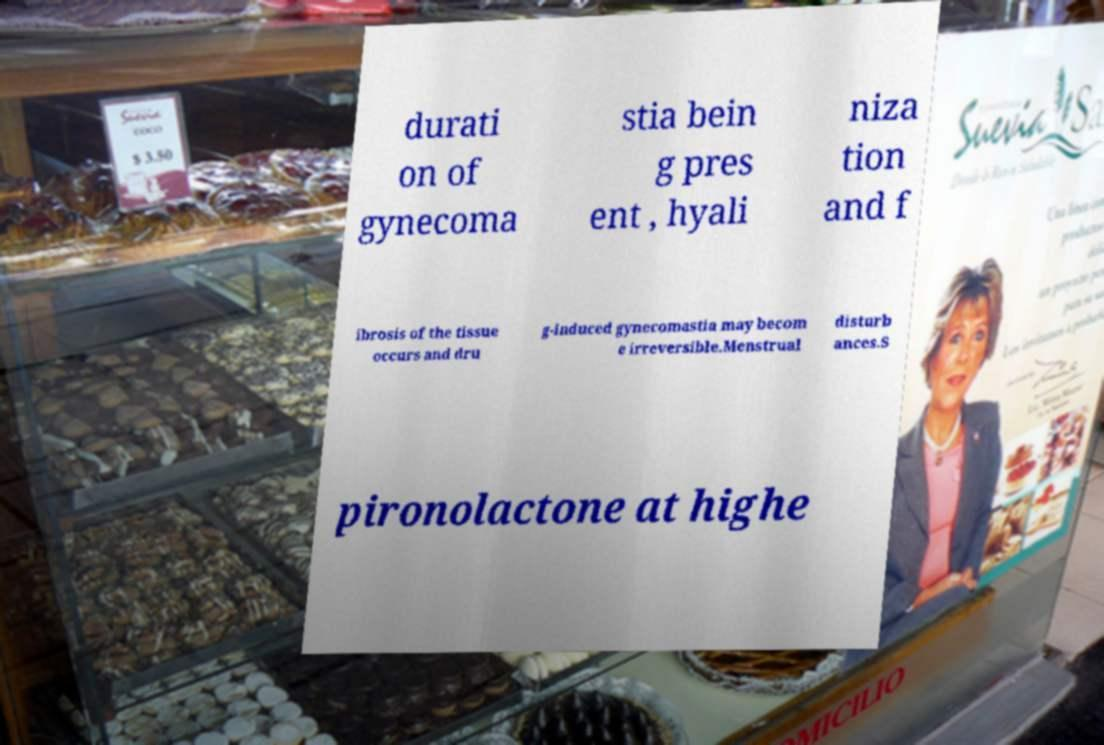Can you read and provide the text displayed in the image?This photo seems to have some interesting text. Can you extract and type it out for me? durati on of gynecoma stia bein g pres ent , hyali niza tion and f ibrosis of the tissue occurs and dru g-induced gynecomastia may becom e irreversible.Menstrual disturb ances.S pironolactone at highe 